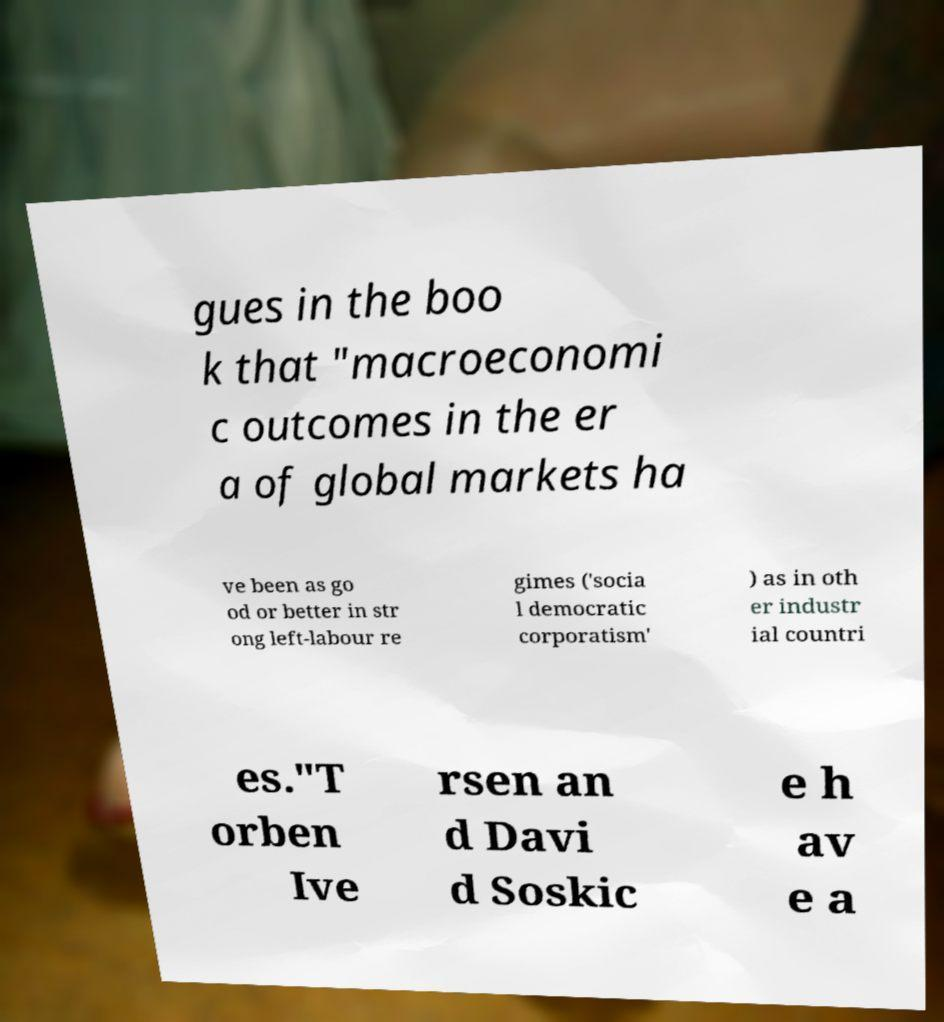There's text embedded in this image that I need extracted. Can you transcribe it verbatim? gues in the boo k that "macroeconomi c outcomes in the er a of global markets ha ve been as go od or better in str ong left-labour re gimes ('socia l democratic corporatism' ) as in oth er industr ial countri es."T orben Ive rsen an d Davi d Soskic e h av e a 